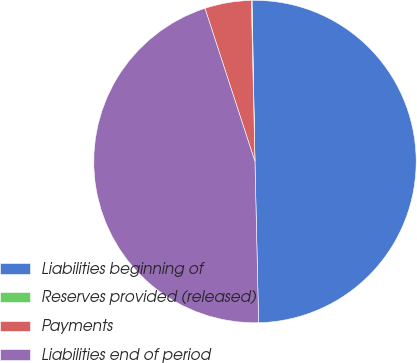Convert chart. <chart><loc_0><loc_0><loc_500><loc_500><pie_chart><fcel>Liabilities beginning of<fcel>Reserves provided (released)<fcel>Payments<fcel>Liabilities end of period<nl><fcel>49.93%<fcel>0.07%<fcel>4.66%<fcel>45.34%<nl></chart> 